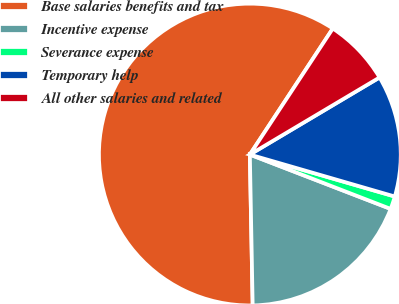Convert chart to OTSL. <chart><loc_0><loc_0><loc_500><loc_500><pie_chart><fcel>Base salaries benefits and tax<fcel>Incentive expense<fcel>Severance expense<fcel>Temporary help<fcel>All other salaries and related<nl><fcel>59.57%<fcel>18.84%<fcel>1.38%<fcel>13.02%<fcel>7.2%<nl></chart> 